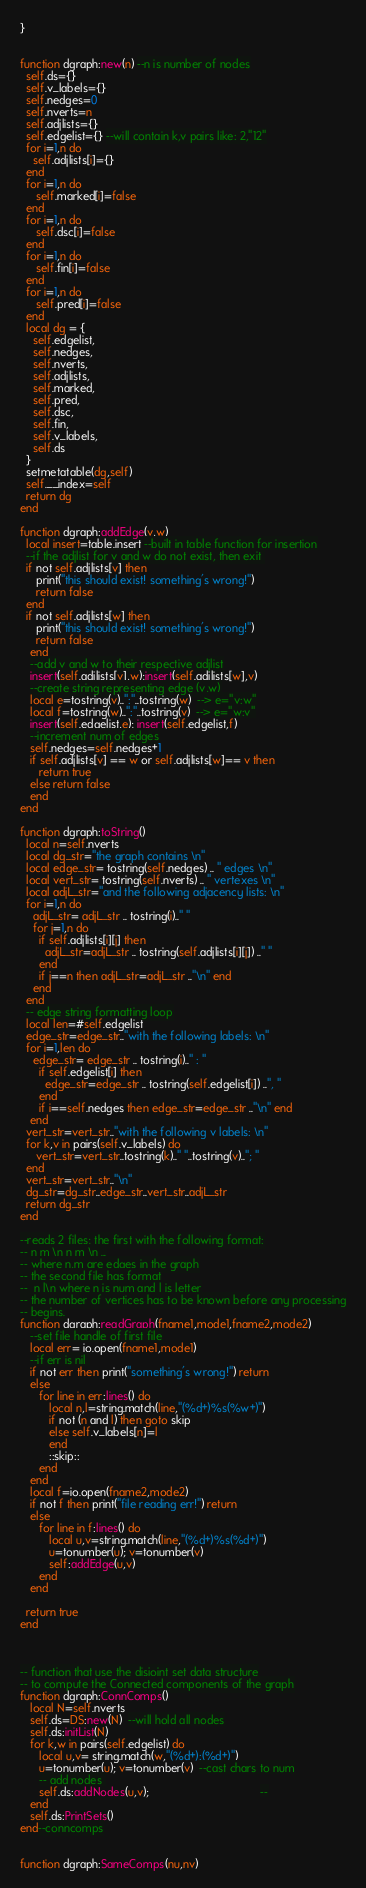Convert code to text. <code><loc_0><loc_0><loc_500><loc_500><_Lua_>}


function dgraph:new(n) --n is number of nodes
  self.ds={}
  self.v_labels={}
  self.nedges=0
  self.nverts=n
  self.adjlists={}
  self.edgelist={} --will contain k,v pairs like: 2,"12"
  for i=1,n do
    self.adjlists[i]={}
  end
  for i=1,n do
     self.marked[i]=false
  end
  for i=1,n do
     self.dsc[i]=false
  end
  for i=1,n do
     self.fin[i]=false
  end
  for i=1,n do
     self.pred[i]=false
  end
  local dg = {
    self.edgelist,
    self.nedges,
    self.nverts,
    self.adjlists,
    self.marked,
    self.pred,
    self.dsc,
    self.fin,
    self.v_labels,
    self.ds
  }
  setmetatable(dg,self)
  self.__index=self
  return dg
end
 
function dgraph:addEdge(v,w)
  local insert=table.insert --built in table function for insertion
  --if the adjlist for v and w do not exist, then exit 
  if not self.adjlists[v] then
     print("this should exist! something's wrong!")
     return false
  end
  if not self.adjlists[w] then
     print("this should exist! something's wrong!")
     return false
   end
   --add v and w to their respective adjlist
   insert(self.adjlists[v],w);insert(self.adjlists[w],v)
   --create string representing edge (v,w)
   local e=tostring(v)..":"..tostring(w)  --> e="v:w"
   local f=tostring(w)..":"..tostring(v)  --> e="w:v"
   insert(self.edgelist,e); insert(self.edgelist,f)
   --increment num of edges
   self.nedges=self.nedges+1 
   if self.adjlists[v] == w or self.adjlists[w]== v then
      return true
   else return false
   end
end

function dgraph:toString()
  local n=self.nverts
  local dg_str="the graph contains \n"
  local edge_str= tostring(self.nedges) .. " edges \n"
  local vert_str= tostring(self.nverts) .. " vertexes \n"
  local adjL_str="and the following adjacency lists: \n"
  for i=1,n do
    adjL_str= adjL_str .. tostring(i).." "
    for j=1,n do
      if self.adjlists[i][j] then
        adjL_str=adjL_str .. tostring(self.adjlists[i][j]) .." "
      end
      if j==n then adjL_str=adjL_str .."\n" end
    end
  end
  -- edge string formatting loop
  local len=#self.edgelist
  edge_str=edge_str.."with the following labels: \n"
  for i=1,len do
    edge_str= edge_str .. tostring(i).." : "
      if self.edgelist[i] then
        edge_str=edge_str .. tostring(self.edgelist[i]) ..", "
      end
      if i==self.nedges then edge_str=edge_str .."\n" end
   end
  vert_str=vert_str.."with the following v labels: \n"
  for k,v in pairs(self.v_labels) do
     vert_str=vert_str..tostring(k).." "..tostring(v).."; "
  end
  vert_str=vert_str.."\n"
  dg_str=dg_str..edge_str..vert_str..adjL_str
  return dg_str
end

--reads 2 files; the first with the following format:
-- n m \n n m \n ...
-- where n,m are edges in the graph
-- the second file has format
--  n l\n where n is num and l is letter
-- the number of vertices has to be known before any processing
-- begins.
function dgraph:readGraph(fname1,mode1,fname2,mode2)
   --set file handle of first file
   local err= io.open(fname1,mode1)
   --if err is nil 
   if not err then print("something's wrong!") return 
   else
      for line in err:lines() do
         local n,l=string.match(line,"(%d+)%s(%w+)")
         if not (n and l) then goto skip
         else self.v_labels[n]=l
         end
         ::skip::
      end
   end
   local f=io.open(fname2,mode2)
   if not f then print("file reading err!") return
   else
      for line in f:lines() do
         local u,v=string.match(line,"(%d+)%s(%d+)")
         u=tonumber(u); v=tonumber(v)
         self:addEdge(u,v)
      end
   end
   
  return true
end



-- function that use the disjoint set data structure
-- to compute the Connected components of the graph
function dgraph:ConnComps()
   local N=self.nverts
   self.ds=DS:new(N)  --will hold all nodes
   self.ds:initList(N)
   for k,w in pairs(self.edgelist) do
      local u,v= string.match(w,"(%d+):(%d+)")
      u=tonumber(u); v=tonumber(v)  --cast chars to num
      -- add nodes 
      self.ds:addNodes(u,v);                                   --
   end
   self.ds:PrintSets()
end--conncomps


function dgraph:SameComps(nu,nv)</code> 